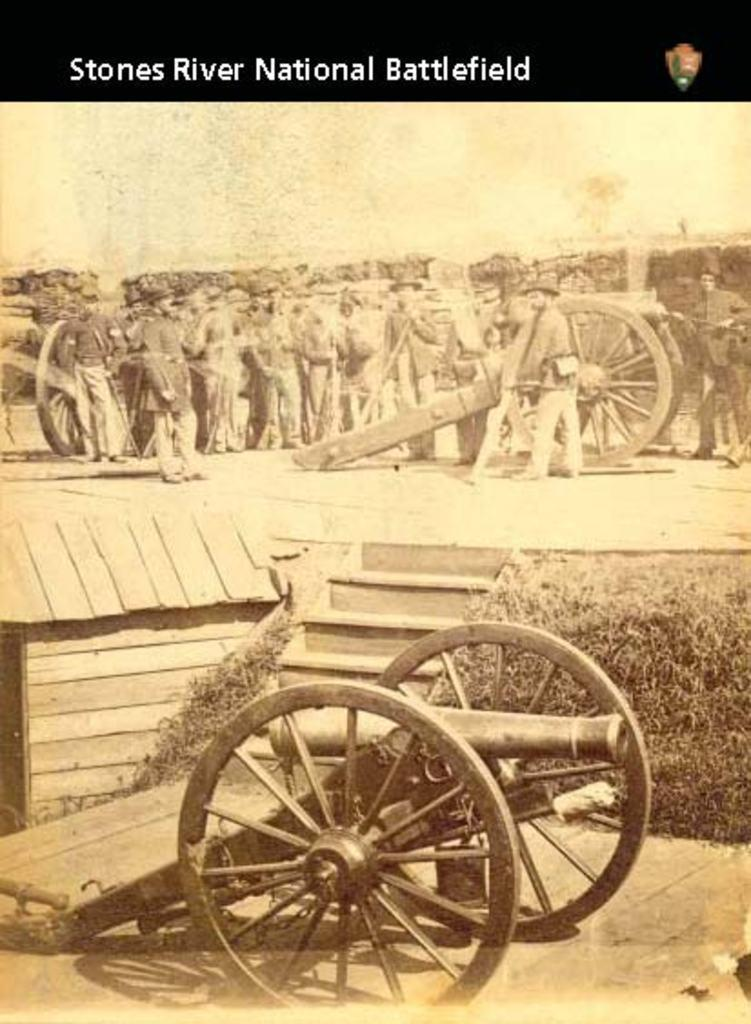How many people are present in the image? There are many people in the image. What type of objects can be seen in the image? There are canons, staircases, and plants in the image. Can you describe the setting of the image? The image features many people, canons, staircases, and plants, suggesting a historical or military setting. Are there any girls playing in the image? There is no information about girls or playing in the image; it only mentions the presence of many people, canons, staircases, and plants. 